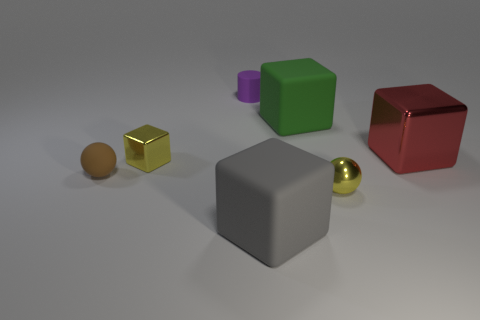How many yellow things are large rubber blocks or tiny balls?
Provide a succinct answer. 1. Is the number of purple cylinders greater than the number of tiny brown metallic cylinders?
Provide a short and direct response. Yes. Is the size of the yellow shiny thing in front of the small rubber sphere the same as the block that is on the left side of the gray matte block?
Your answer should be very brief. Yes. The large rubber object that is in front of the metallic thing that is to the left of the tiny yellow thing on the right side of the tiny purple rubber cylinder is what color?
Offer a very short reply. Gray. Are there any other small matte objects that have the same shape as the small brown thing?
Your answer should be compact. No. Are there more tiny brown matte balls that are on the right side of the tiny yellow sphere than tiny rubber objects?
Make the answer very short. No. How many rubber objects are big red blocks or gray spheres?
Offer a terse response. 0. What size is the cube that is in front of the big metal cube and behind the tiny rubber ball?
Ensure brevity in your answer.  Small. Is there a tiny brown rubber object on the left side of the metal block that is in front of the red cube?
Your answer should be compact. Yes. There is a yellow shiny sphere; what number of brown matte spheres are to the left of it?
Make the answer very short. 1. 